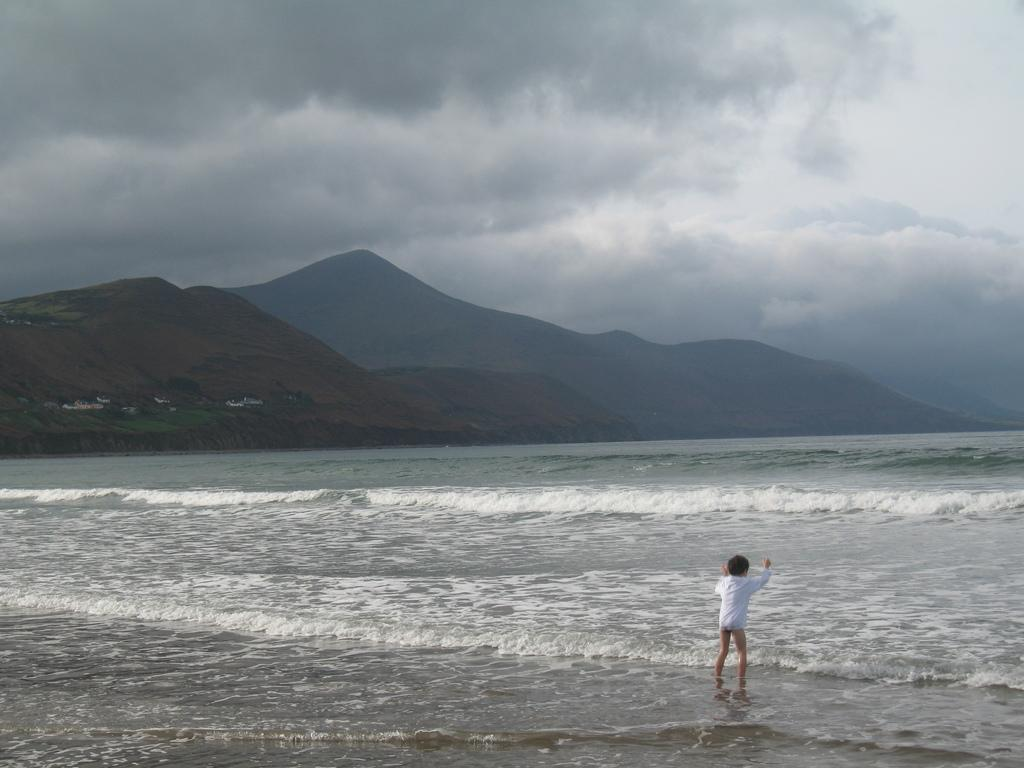What is the main subject of the image? There is a person standing in the image. Where is the person standing in relation to the water? The person is standing in front of the water. What can be seen in the background of the image? There are mountains visible in the background of the image, and the sky is cloudy. How many kittens are playing in the middle of the water in the image? There are no kittens present in the image, and therefore no such activity can be observed. 